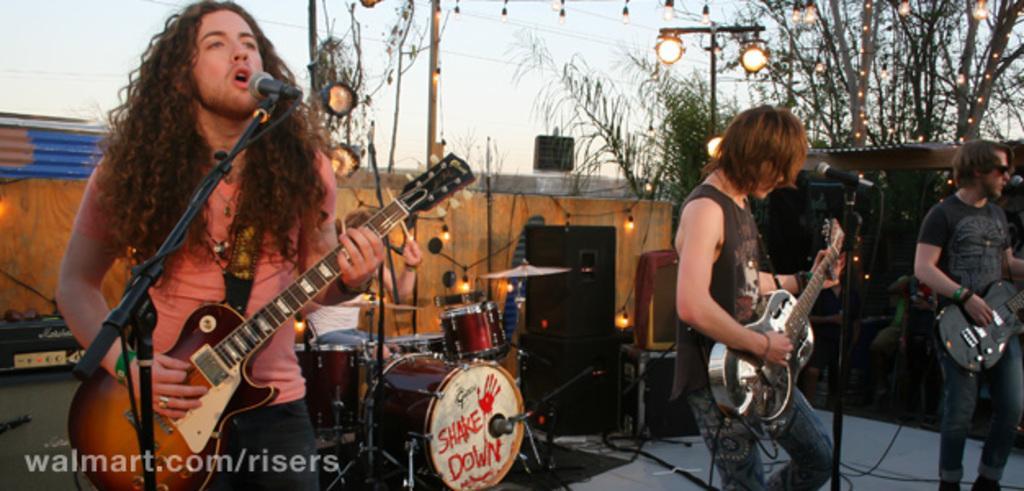In one or two sentences, can you explain what this image depicts? In this image I can see three person standing and playing musical instrument. There is a mic and a stand. 